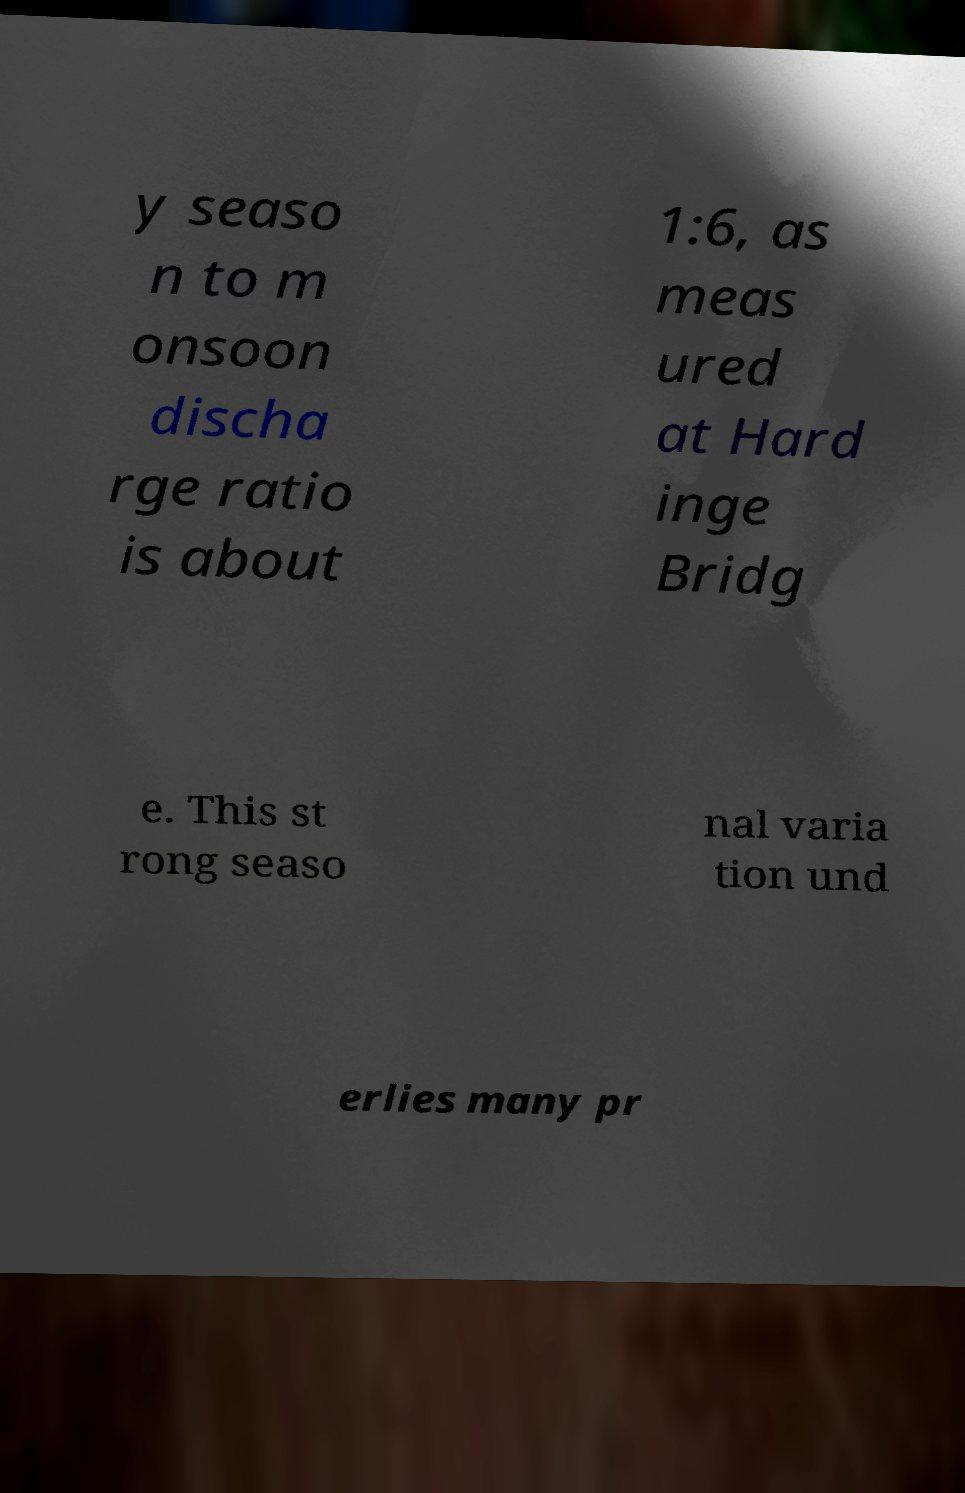What messages or text are displayed in this image? I need them in a readable, typed format. y seaso n to m onsoon discha rge ratio is about 1:6, as meas ured at Hard inge Bridg e. This st rong seaso nal varia tion und erlies many pr 